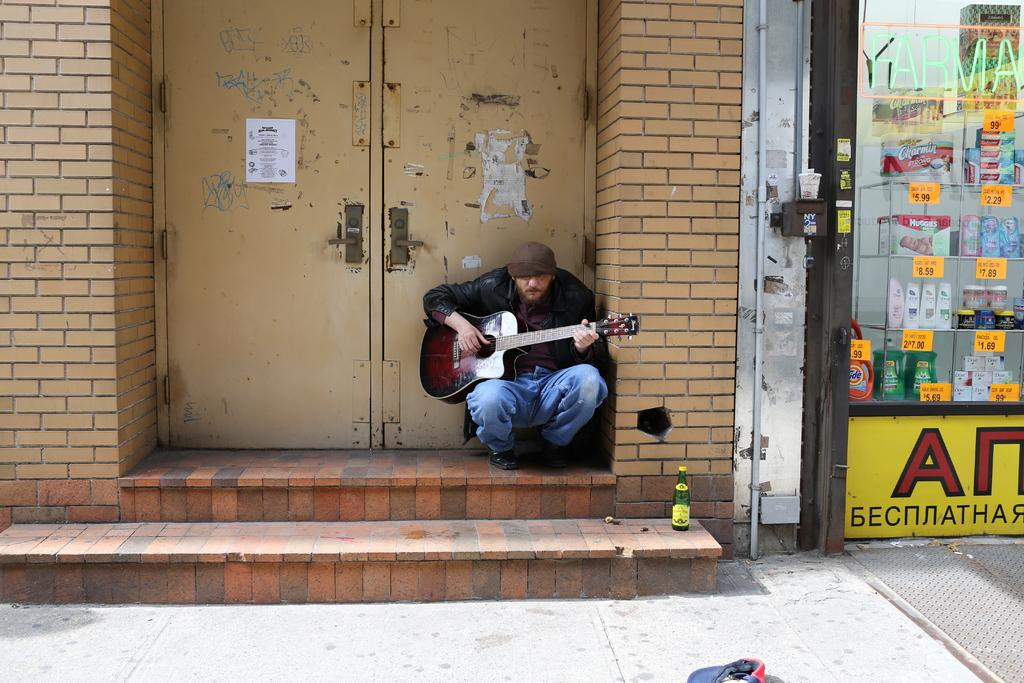Who is present in the image? There is a guy in the image. What is the guy doing in the image? The guy is sitting on a road and holding a guitar. What object is beside the guy? There is a glass bottle beside the guy. What can be seen in the background of the image? There is a door and a brick wall in the background of the image. How many dolls are sitting next to the guy playing the sail in the image? There are no dolls or sail present in the image. Can you see any rabbits hopping around the guy with the guitar in the image? There are no rabbits visible in the image. 